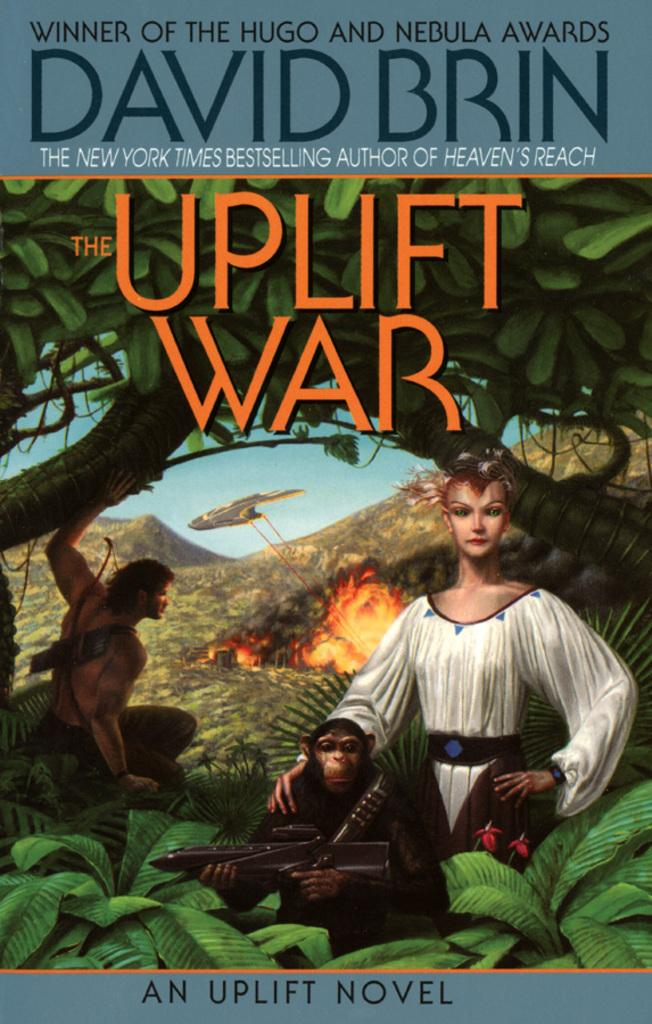What is the main feature of the image? There is a poster in the image. What can be found on the poster? The poster contains text and has a picture of a man and a woman, as well as a picture of an animal holding a gun. What other elements are present in the image? There are trees, a mountain, fire, a flying object, and the sky is visible. What is the distance between the man and the woman in the image? The image does not provide information about the distance between the man and the woman; it only shows a picture of them on the poster. What is the name of the animal holding a gun in the image? The image does not specify the name of the animal holding a gun; it only shows a picture of the animal with a gun. 